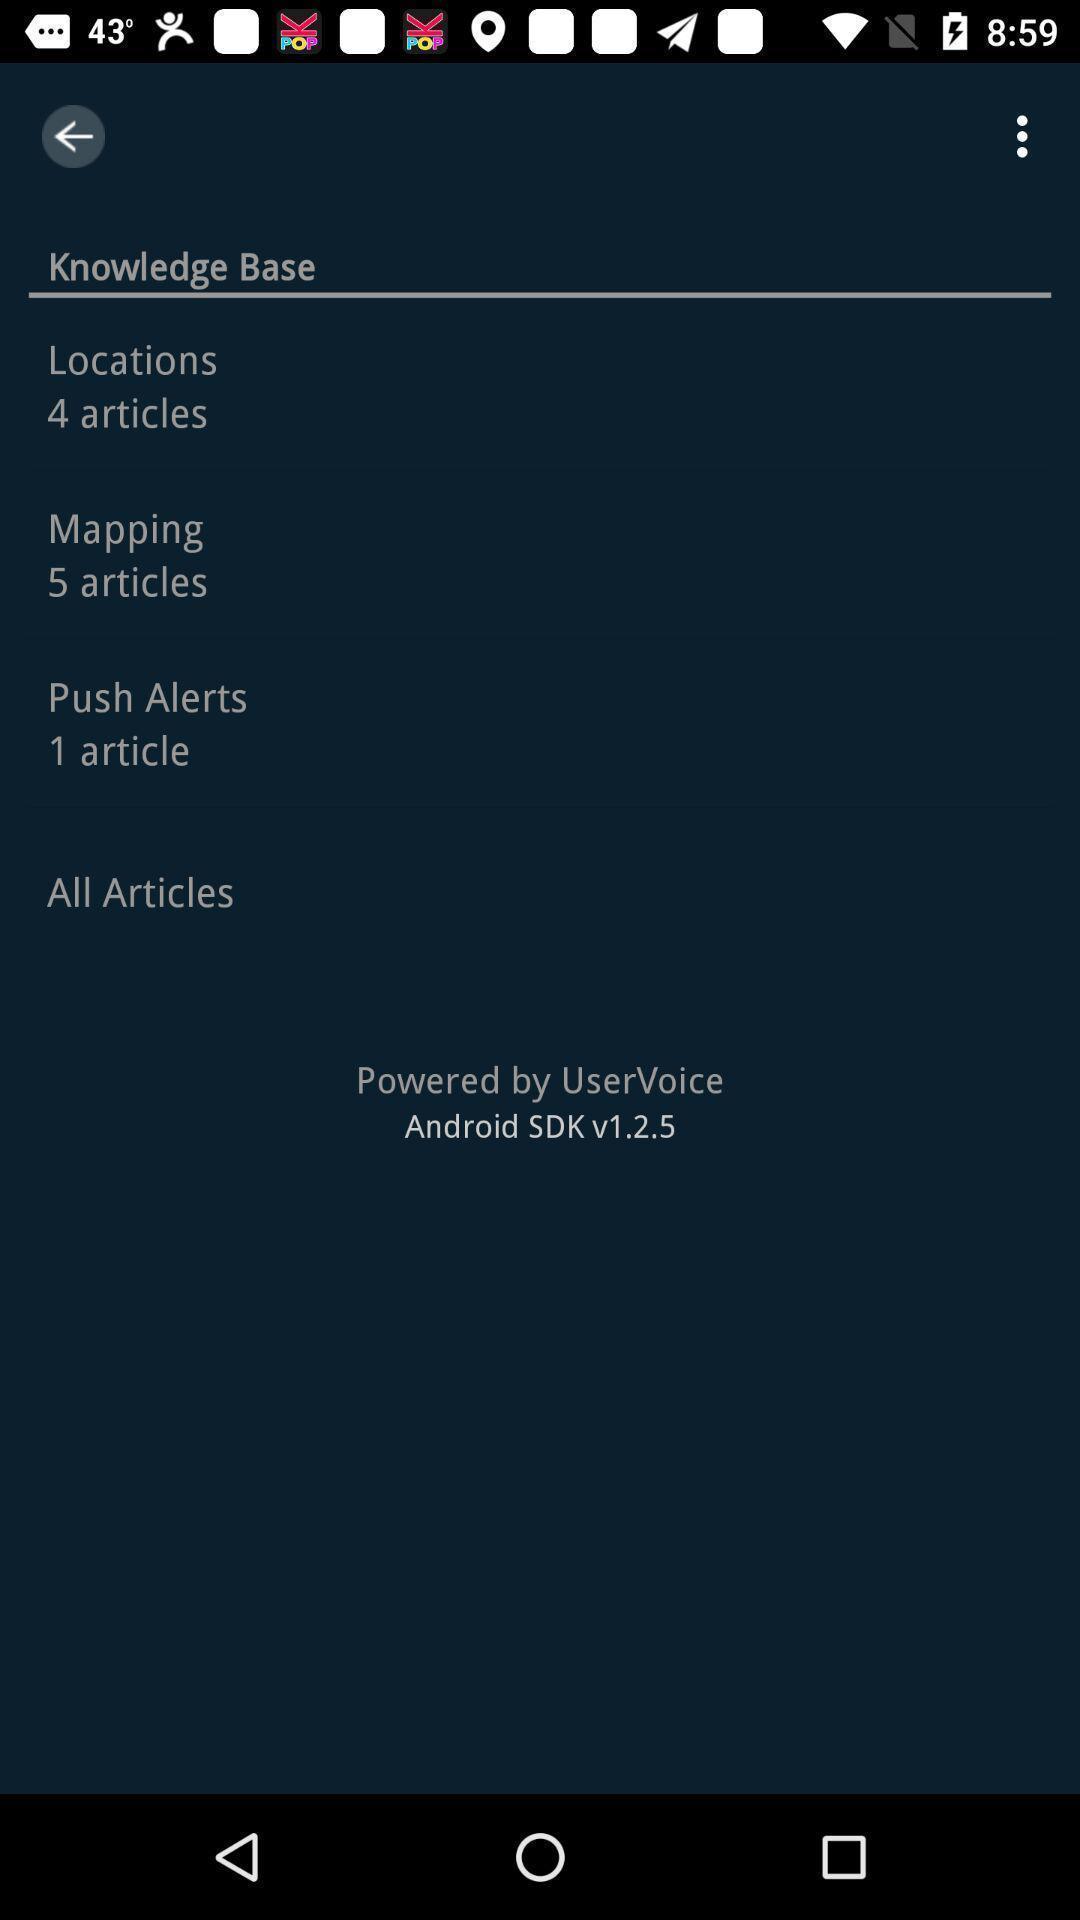Summarize the information in this screenshot. Page showing different articles available in application. 